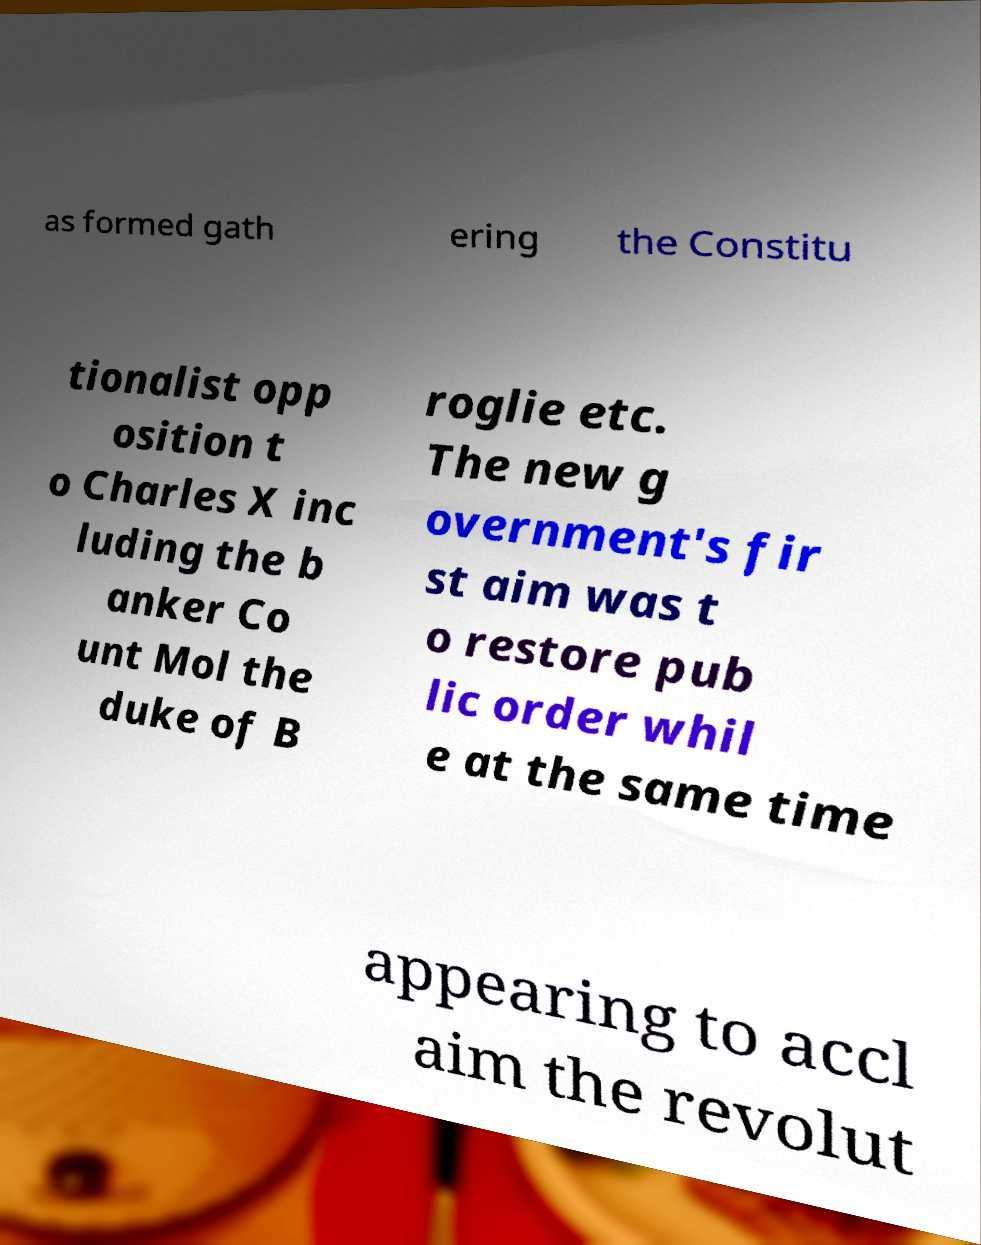Can you accurately transcribe the text from the provided image for me? as formed gath ering the Constitu tionalist opp osition t o Charles X inc luding the b anker Co unt Mol the duke of B roglie etc. The new g overnment's fir st aim was t o restore pub lic order whil e at the same time appearing to accl aim the revolut 